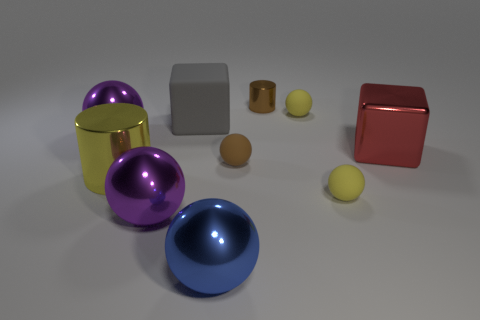What number of other objects are the same color as the small shiny object?
Your answer should be compact. 1. There is a metal cylinder on the right side of the large blue object; does it have the same size as the yellow sphere behind the big yellow metal object?
Your answer should be compact. Yes. There is a shiny cylinder that is on the left side of the gray matte cube; what color is it?
Offer a very short reply. Yellow. Is the number of large blue spheres behind the large gray matte block less than the number of big yellow shiny things?
Provide a succinct answer. Yes. Is the big gray cube made of the same material as the tiny brown sphere?
Offer a terse response. Yes. What is the size of the red shiny object that is the same shape as the big gray matte thing?
Keep it short and to the point. Large. How many objects are shiny spheres in front of the big yellow thing or big balls on the left side of the red metal thing?
Your response must be concise. 3. Are there fewer matte spheres than purple balls?
Make the answer very short. No. There is a brown rubber sphere; is its size the same as the cube that is on the right side of the large gray cube?
Offer a terse response. No. What number of rubber objects are either gray objects or tiny green things?
Provide a short and direct response. 1. 